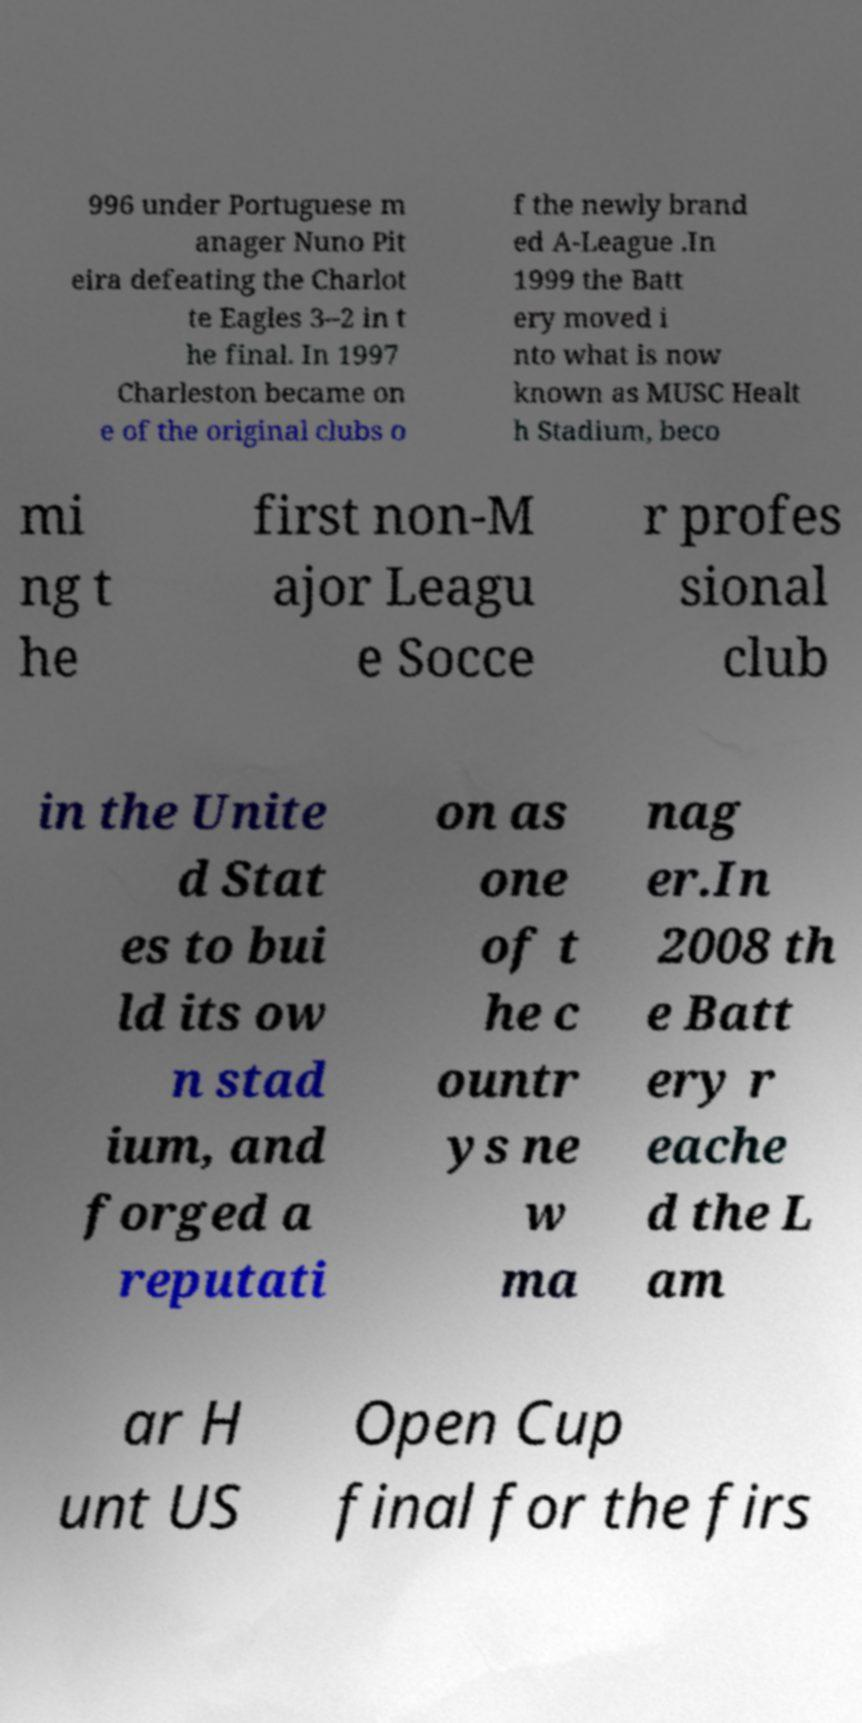I need the written content from this picture converted into text. Can you do that? 996 under Portuguese m anager Nuno Pit eira defeating the Charlot te Eagles 3–2 in t he final. In 1997 Charleston became on e of the original clubs o f the newly brand ed A-League .In 1999 the Batt ery moved i nto what is now known as MUSC Healt h Stadium, beco mi ng t he first non-M ajor Leagu e Socce r profes sional club in the Unite d Stat es to bui ld its ow n stad ium, and forged a reputati on as one of t he c ountr ys ne w ma nag er.In 2008 th e Batt ery r eache d the L am ar H unt US Open Cup final for the firs 